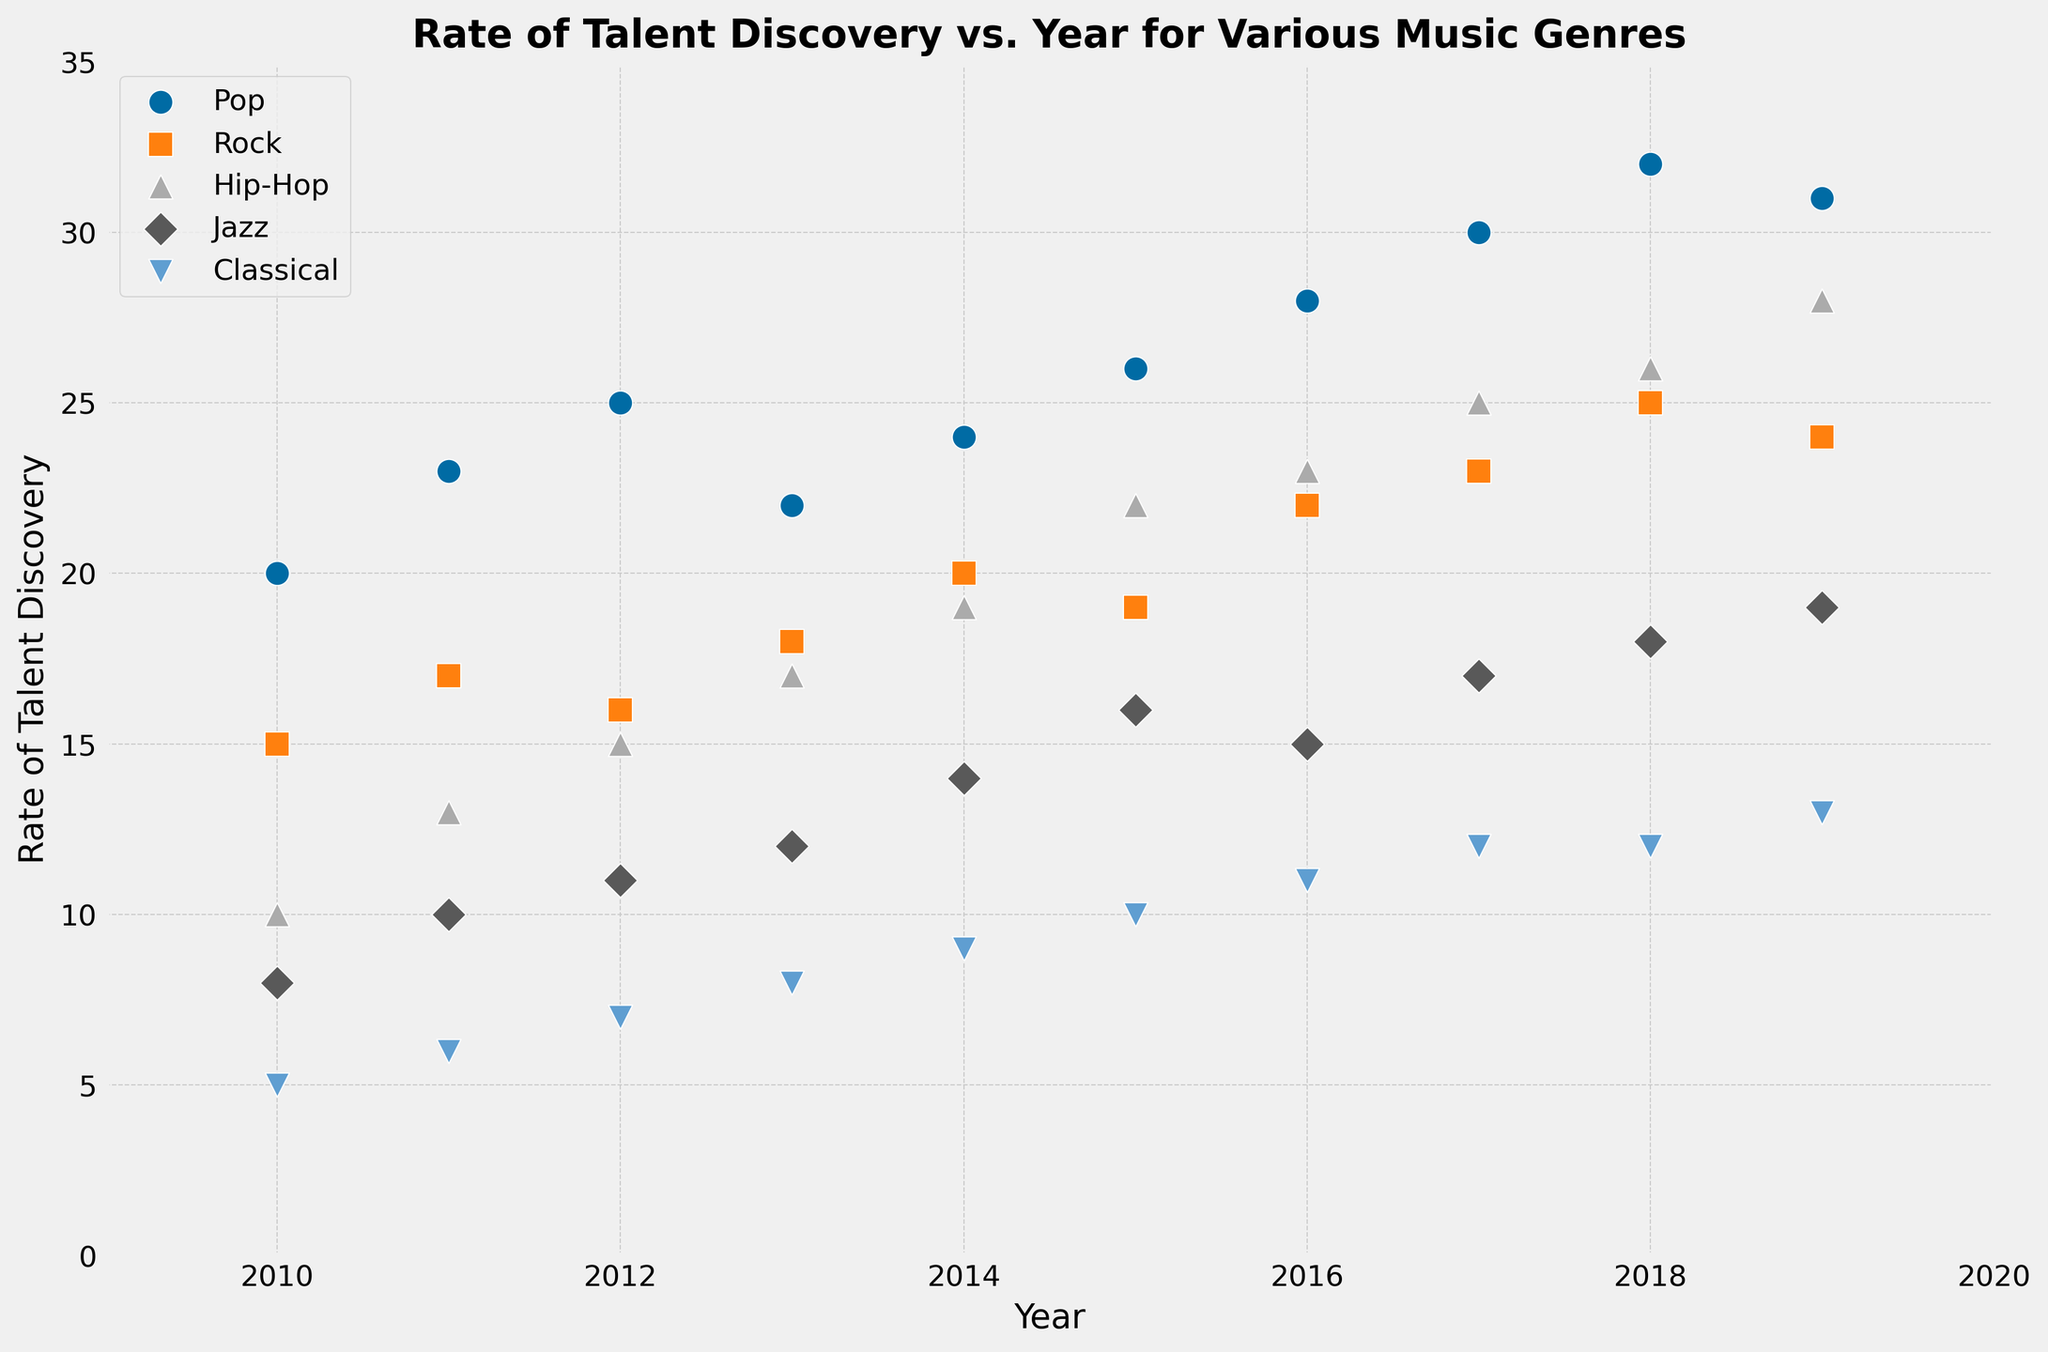What is the overall trend in the rate of talent discovery for Pop music from 2010 to 2019? To identify the trend, observe the scatter points for Pop music from 2010 to 2019. Notice the overall direction: starting at 20 in 2010 and gradually increasing to 31 by 2019. Despite some fluctuations, the general trend is upward.
Answer: Upward Which genre had the highest rate of talent discovery in 2019? Compare the scatter points for all genres in 2019. Pop has the highest rate at 31, followed by Hip-Hop at 28. Thus, Pop leads in 2019.
Answer: Pop How did the rate of talent discovery for Rock music change between 2015 and 2019? Locate the points for Rock music in 2015 (19) and 2019 (24). Subtract the rate in 2015 from the rate in 2019: 24 - 19 = 5. The rate increased by 5.
Answer: Increased by 5 Which genre shows the most consistent growth in talent discovery rate over the years? Look for a genre with minimal fluctuations and a steady upward trend in the scatter points over the years. Classical music shows steady growth with nearly a straight line from 5 in 2010 to 13 in 2019.
Answer: Classical Between Hip-Hop and Jazz, which genre had a higher rate of talent discovery in 2014, and by how much? Compare the points for Hip-Hop (19) and Jazz (14) in 2014. Subtract the Jazz rate from the Hip-Hop rate: 19 - 14 = 5. Hip-Hop had a higher rate by 5.
Answer: Hip-Hop, by 5 Which genre had the lowest rate of talent discovery in 2010, and what was the rate? Look at the scatter points for all genres in 2010. Classical has the lowest rate at 5.
Answer: Classical, 5 What was the average rate of talent discovery for Pop music over the entire period? Sum the rates for Pop music from 2010 to 2019: 20 + 23 + 25 + 22 + 24 + 26 + 28 + 30 + 32 + 31 = 261. Then divide by the number of years (10): 261 / 10 = 26.1.
Answer: 26.1 What is the difference in the rate of talent discovery between Pop and Jazz in 2017? Compare the rates for Pop (30) and Jazz (17) in 2017. Subtract the Jazz rate from the Pop rate: 30 - 17 = 13.
Answer: 13 How many genres had a rate of talent discovery of 20 or higher in 2018? Check the scatter points for each genre in 2018 where the value is 20 or above. Pop (32), Rock (25), Hip-Hop (26), and Jazz (18) qualify. Four genres meet the criteria.
Answer: 4 In which year did the rate of talent discovery for Jazz surpass 15 for the first time? Examine the scatter points for Jazz. It first surpasses 15 in 2015, where the rate is 16.
Answer: 2015 